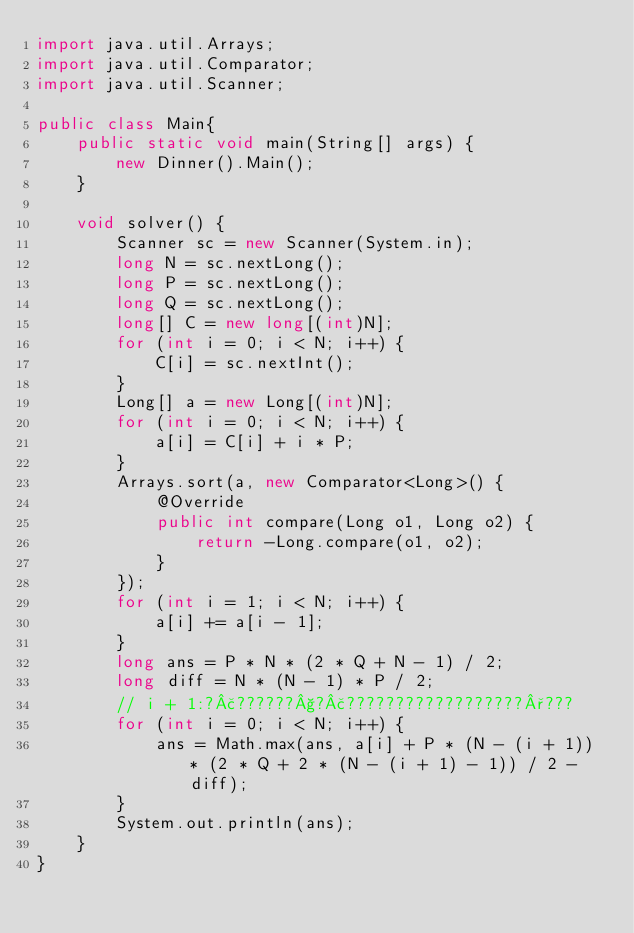Convert code to text. <code><loc_0><loc_0><loc_500><loc_500><_Java_>import java.util.Arrays;
import java.util.Comparator;
import java.util.Scanner;

public class Main{
	public static void main(String[] args) {
		new Dinner().Main();
	}

	void solver() {
		Scanner sc = new Scanner(System.in);
		long N = sc.nextLong();
		long P = sc.nextLong();
		long Q = sc.nextLong();
		long[] C = new long[(int)N];
		for (int i = 0; i < N; i++) {
			C[i] = sc.nextInt();
		}
		Long[] a = new Long[(int)N];
		for (int i = 0; i < N; i++) {
			a[i] = C[i] + i * P;
		}
		Arrays.sort(a, new Comparator<Long>() {
			@Override
			public int compare(Long o1, Long o2) {
				return -Long.compare(o1, o2);
			}
		});
		for (int i = 1; i < N; i++) {
			a[i] += a[i - 1];
		}
		long ans = P * N * (2 * Q + N - 1) / 2;
		long diff = N * (N - 1) * P / 2;
		// i + 1:?£??????§?£??????????????????°???
		for (int i = 0; i < N; i++) {
			ans = Math.max(ans, a[i] + P * (N - (i + 1)) * (2 * Q + 2 * (N - (i + 1) - 1)) / 2 - diff);
		}
		System.out.println(ans);
	}
}</code> 